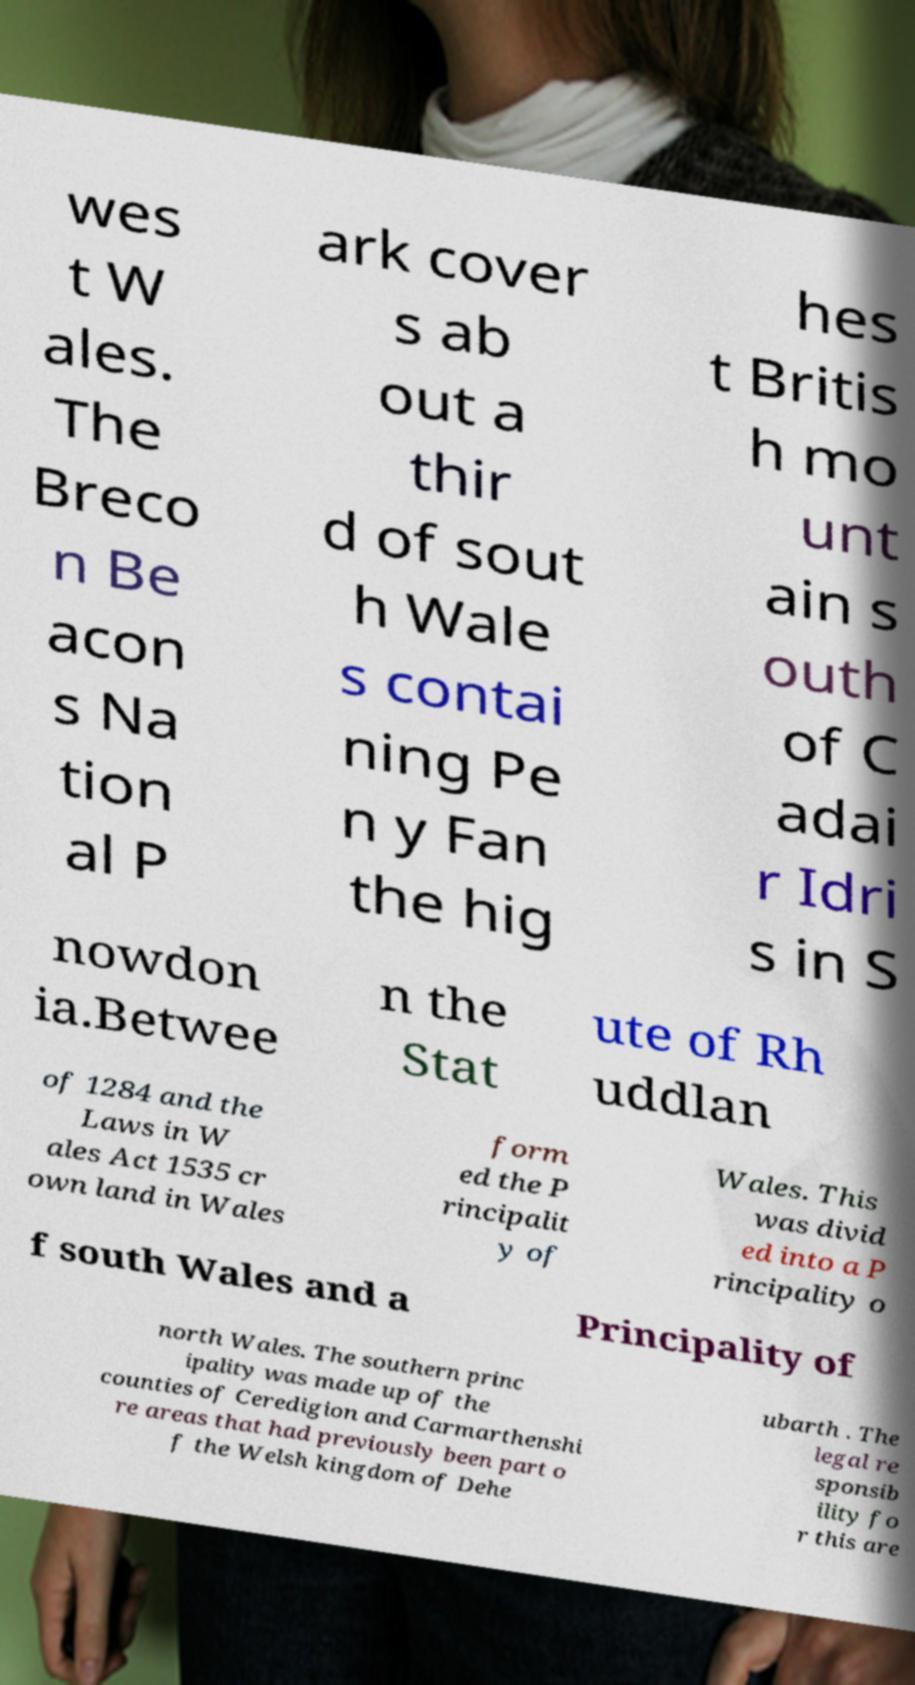What messages or text are displayed in this image? I need them in a readable, typed format. wes t W ales. The Breco n Be acon s Na tion al P ark cover s ab out a thir d of sout h Wale s contai ning Pe n y Fan the hig hes t Britis h mo unt ain s outh of C adai r Idri s in S nowdon ia.Betwee n the Stat ute of Rh uddlan of 1284 and the Laws in W ales Act 1535 cr own land in Wales form ed the P rincipalit y of Wales. This was divid ed into a P rincipality o f south Wales and a Principality of north Wales. The southern princ ipality was made up of the counties of Ceredigion and Carmarthenshi re areas that had previously been part o f the Welsh kingdom of Dehe ubarth . The legal re sponsib ility fo r this are 